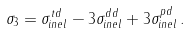<formula> <loc_0><loc_0><loc_500><loc_500>\sigma _ { 3 } = \sigma _ { i n e l } ^ { t d } - 3 \sigma _ { i n e l } ^ { d d } + 3 \sigma _ { i n e l } ^ { p d } \, .</formula> 